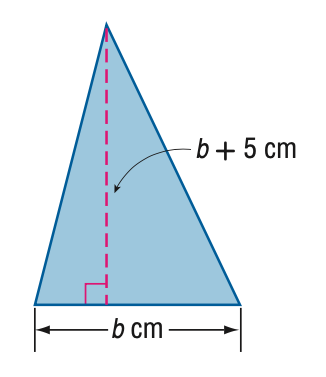Question: The height of a triangle is 5 centimeters more than its base. The area of the triangle is 52 square centimeters. Find the base.
Choices:
A. 5.1
B. 8
C. 9.9
D. 13
Answer with the letter. Answer: B Question: The height of a triangle is 5 centimeters more than its base. The area of the triangle is 52 square centimeters. Find the height.
Choices:
A. 10.1
B. 13
C. 14.9
D. 18
Answer with the letter. Answer: B 